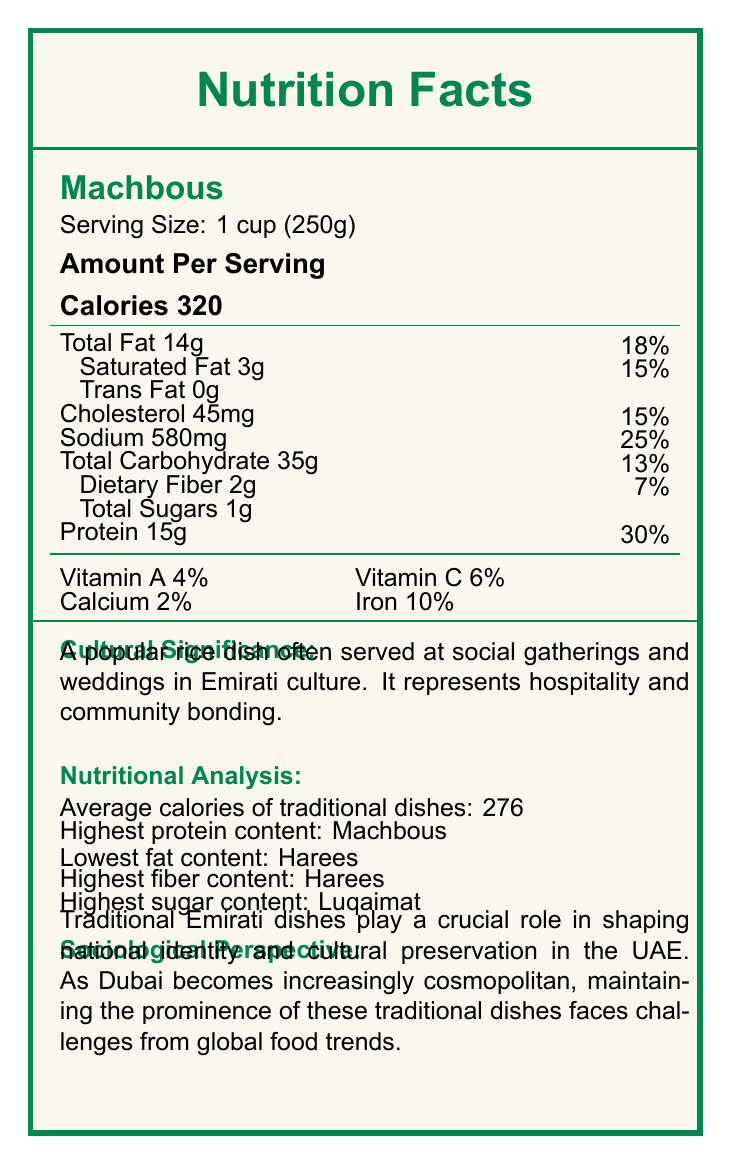what is the average calorie count of the traditional Emirati dishes? The document states the average calorie count in the nutritional analysis section, specifying it as 276.
Answer: 276 which traditional Emirati dish has the highest protein content? According to the nutritional analysis, Machbous has the highest protein content.
Answer: Machbous which dish has the lowest fat content? The nutritional analysis section indicates that Harees has the lowest fat content.
Answer: Harees which traditional dish is rich in fiber? The nutritional analysis section shows that Harees has the highest fiber content.
Answer: Harees what is the cultural significance of Luqaimat? The cultural significance of Luqaimat is given in the document, stating it is a popular sweet dessert often served during Iftar in Ramadan.
Answer: A popular sweet dessert often served during Iftar in Ramadan what percentage of daily sodium value does Machbous provide? The information is given in the Machbous nutrition facts section where sodium content is 580mg, equating to 25% of the daily value.
Answer: 25% what is the serving size of Thereed? The serving size of Thereed is specified as 1 cup (250g) in the document.
Answer: 1 cup (250g) how much total carbohydrates does Balaleet contain? Balaleet contains 45g of total carbohydrates, as listed in its nutrition facts.
Answer: 45g which vitamin is completely absent in both Harees and Luqaimat? A. Vitamin A B. Vitamin C C. Calcium D. Iron Both Harees and Luqaimat have 0% Vitamin C listed in their nutritional contents.
Answer: B. Vitamin C how many traditional Emirati dishes are compared in the document? A. Three B. Five C. Seven D. Four The document lists and compares five traditional Emirati dishes.
Answer: B. Five do traditional Emirati dishes contribute to social cohesion? The sociological perspective section states that shared meals featuring traditional dishes strengthen social bonds and reinforce cultural values within Emirati communities.
Answer: Yes summarize the main idea of the document. The document includes a nutritional breakdown of five traditional Emirati dishes, highlighting their serving size, calorie count, and various nutrients. Additionally, it explores their cultural significance and the role they play in Emirati society, emphasizing their importance in social cohesion, cultural preservation, and national identity.
Answer: The document provides detailed nutritional information for several traditional Emirati dishes, comparing their calorie and nutrient content, and discusses the cultural significance and sociological impact of these dishes in the UAE. what is the percentage of daily value for calcium in Balaleet? The document states the daily value for calcium as 6% but does not provide the daily reference value amount to back this percentage.
Answer: Cannot be determined 